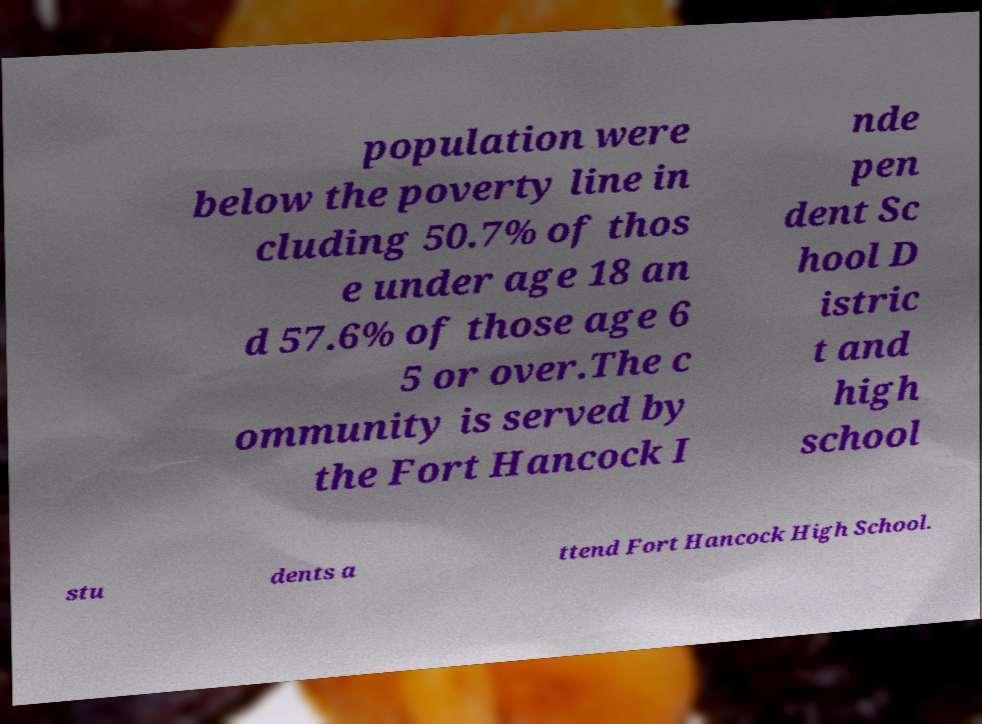What messages or text are displayed in this image? I need them in a readable, typed format. population were below the poverty line in cluding 50.7% of thos e under age 18 an d 57.6% of those age 6 5 or over.The c ommunity is served by the Fort Hancock I nde pen dent Sc hool D istric t and high school stu dents a ttend Fort Hancock High School. 